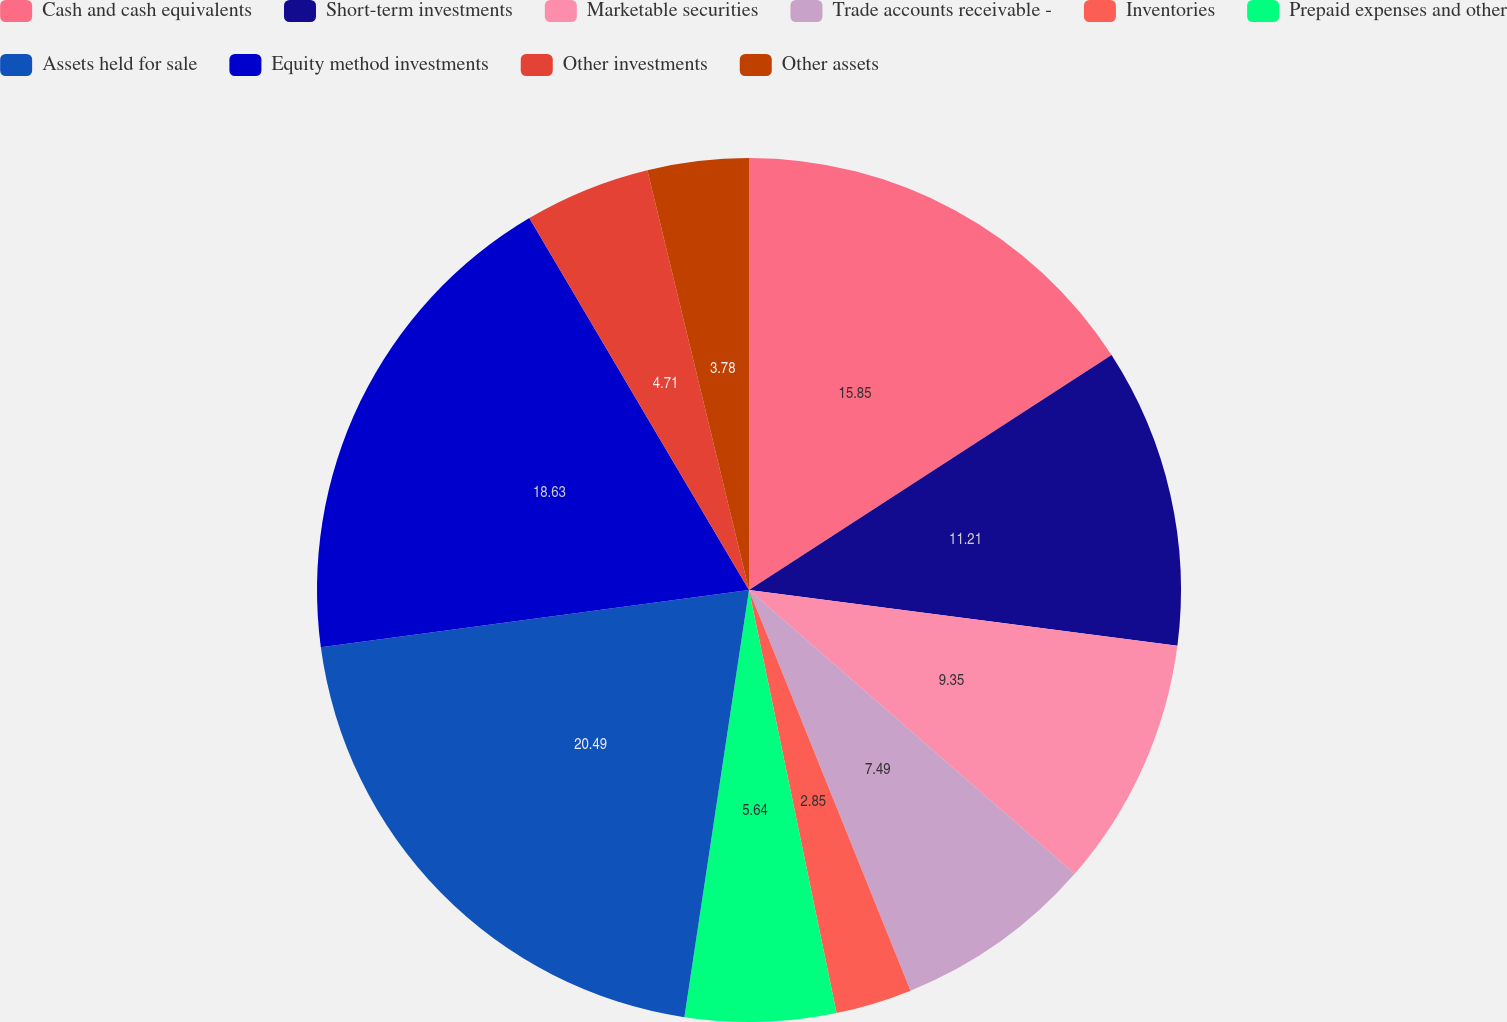<chart> <loc_0><loc_0><loc_500><loc_500><pie_chart><fcel>Cash and cash equivalents<fcel>Short-term investments<fcel>Marketable securities<fcel>Trade accounts receivable -<fcel>Inventories<fcel>Prepaid expenses and other<fcel>Assets held for sale<fcel>Equity method investments<fcel>Other investments<fcel>Other assets<nl><fcel>15.85%<fcel>11.21%<fcel>9.35%<fcel>7.49%<fcel>2.85%<fcel>5.64%<fcel>20.49%<fcel>18.63%<fcel>4.71%<fcel>3.78%<nl></chart> 